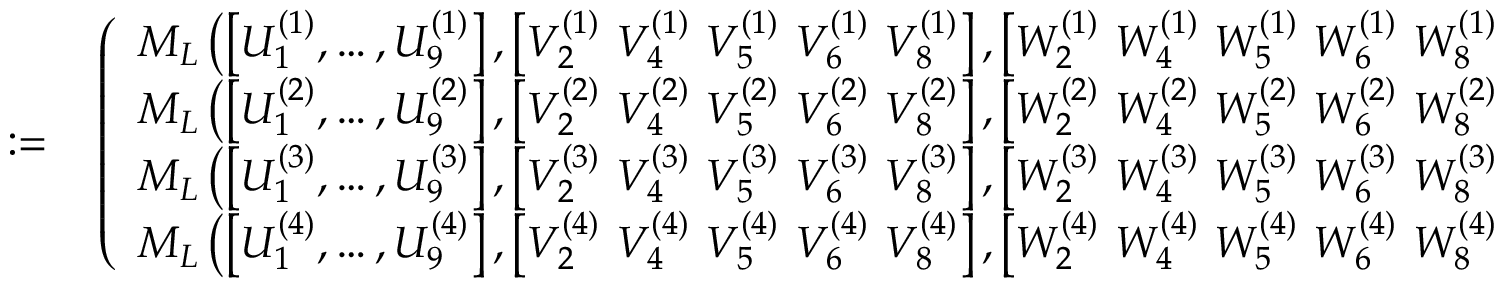<formula> <loc_0><loc_0><loc_500><loc_500>\begin{array} { r l } { \colon = } & \left ( \begin{array} { l } { M _ { L } \left ( \left [ { U } _ { 1 } ^ { ( 1 ) } , \dots , { U } _ { 9 } ^ { ( 1 ) } \right ] , \left [ { V } _ { 2 } ^ { ( 1 ) } { V } _ { 4 } ^ { ( 1 ) } { V } _ { 5 } ^ { ( 1 ) } { V } _ { 6 } ^ { ( 1 ) } { V } _ { 8 } ^ { ( 1 ) } \right ] , \left [ { W } _ { 2 } ^ { ( 1 ) } { W } _ { 4 } ^ { ( 1 ) } { W } _ { 5 } ^ { ( 1 ) } { W } _ { 6 } ^ { ( 1 ) } { W } _ { 8 } ^ { ( 1 ) } \right ] , \xi , \eta \right ) } \\ { M _ { L } \left ( \left [ { U } _ { 1 } ^ { ( 2 ) } , \dots , { U } _ { 9 } ^ { ( 2 ) } \right ] , \left [ { V } _ { 2 } ^ { ( 2 ) } { V } _ { 4 } ^ { ( 2 ) } { V } _ { 5 } ^ { ( 2 ) } { V } _ { 6 } ^ { ( 2 ) } { V } _ { 8 } ^ { ( 2 ) } \right ] , \left [ { W } _ { 2 } ^ { ( 2 ) } { W } _ { 4 } ^ { ( 2 ) } { W } _ { 5 } ^ { ( 2 ) } { W } _ { 6 } ^ { ( 2 ) } { W } _ { 8 } ^ { ( 2 ) } \right ] , \xi , \eta \right ) } \\ { M _ { L } \left ( \left [ { U } _ { 1 } ^ { ( 3 ) } , \dots , { U } _ { 9 } ^ { ( 3 ) } \right ] , \left [ { V } _ { 2 } ^ { ( 3 ) } { V } _ { 4 } ^ { ( 3 ) } { V } _ { 5 } ^ { ( 3 ) } { V } _ { 6 } ^ { ( 3 ) } { V } _ { 8 } ^ { ( 3 ) } \right ] , \left [ { W } _ { 2 } ^ { ( 3 ) } { W } _ { 4 } ^ { ( 3 ) } { W } _ { 5 } ^ { ( 3 ) } { W } _ { 6 } ^ { ( 3 ) } { W } _ { 8 } ^ { ( 3 ) } \right ] , \xi , \eta \right ) } \\ { M _ { L } \left ( \left [ { U } _ { 1 } ^ { ( 4 ) } , \dots , { U } _ { 9 } ^ { ( 4 ) } \right ] , \left [ { V } _ { 2 } ^ { ( 4 ) } { V } _ { 4 } ^ { ( 4 ) } { V } _ { 5 } ^ { ( 4 ) } { V } _ { 6 } ^ { ( 4 ) } { V } _ { 8 } ^ { ( 4 ) } \right ] , \left [ { W } _ { 2 } ^ { ( 4 ) } { W } _ { 4 } ^ { ( 4 ) } { W } _ { 5 } ^ { ( 4 ) } { W } _ { 6 } ^ { ( 4 ) } { W } _ { 8 } ^ { ( 4 ) } \right ] , \xi , \eta \right ) } \end{array} \right ) , } \end{array}</formula> 